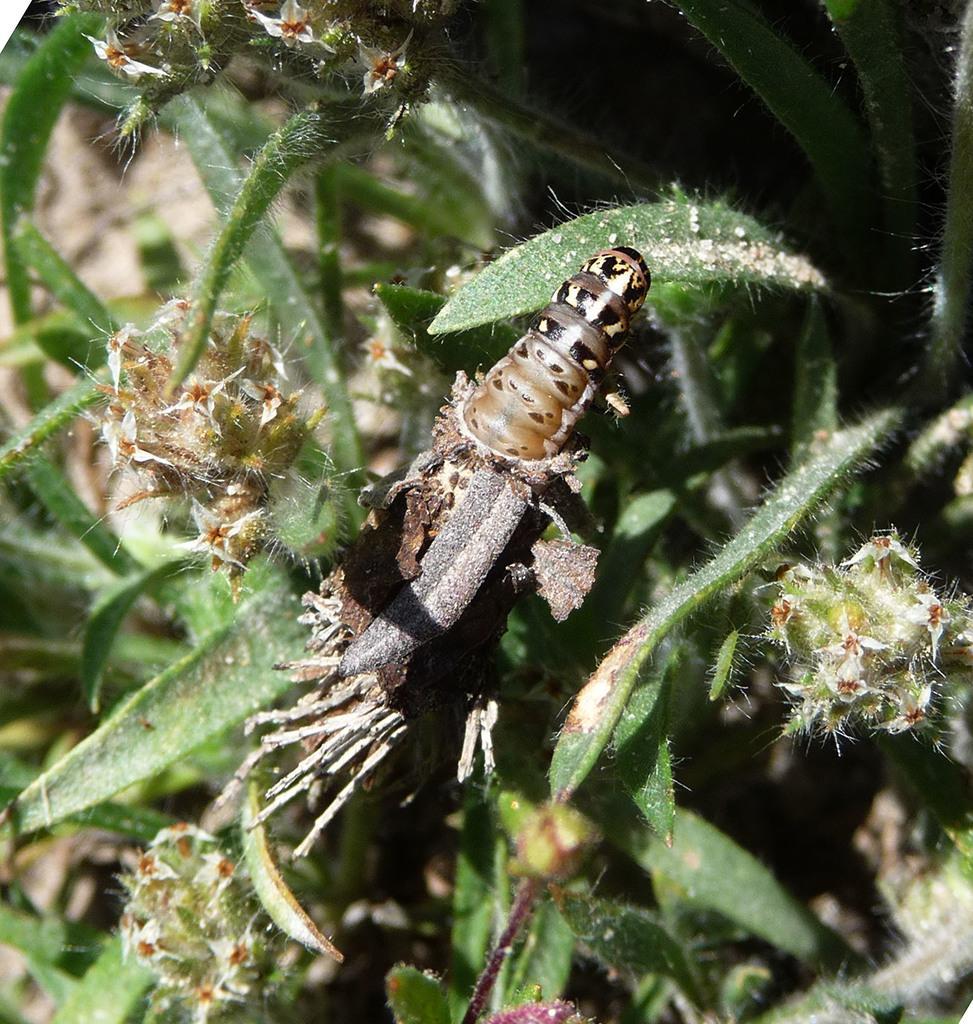Please provide a concise description of this image. In this image we can see insect on a plant. 